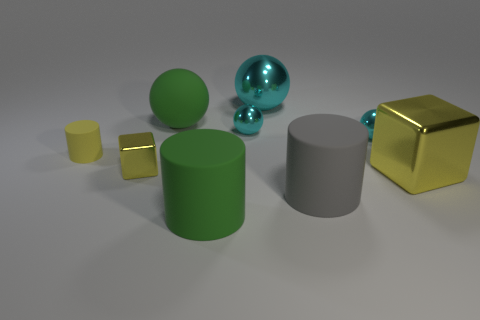How many tiny matte cylinders are in front of the matte thing to the right of the cyan shiny sphere that is behind the green rubber sphere?
Your answer should be compact. 0. Does the green rubber thing behind the yellow cylinder have the same size as the cylinder to the right of the big green rubber cylinder?
Ensure brevity in your answer.  Yes. There is a large thing that is behind the big green rubber thing behind the big yellow metallic block; what is its material?
Your answer should be compact. Metal. How many things are either yellow metal cubes that are on the left side of the big cyan thing or rubber objects?
Keep it short and to the point. 5. Are there the same number of green matte spheres to the right of the big yellow thing and yellow blocks on the left side of the tiny metallic cube?
Provide a succinct answer. Yes. What is the material of the small yellow thing right of the thing left of the yellow metallic thing that is on the left side of the big cube?
Offer a terse response. Metal. What size is the matte object that is to the right of the tiny yellow cylinder and behind the tiny yellow shiny block?
Keep it short and to the point. Large. Does the tiny yellow metallic thing have the same shape as the big yellow thing?
Provide a succinct answer. Yes. The small object that is the same material as the large gray thing is what shape?
Your response must be concise. Cylinder. How many tiny things are rubber cylinders or gray cylinders?
Provide a short and direct response. 1. 